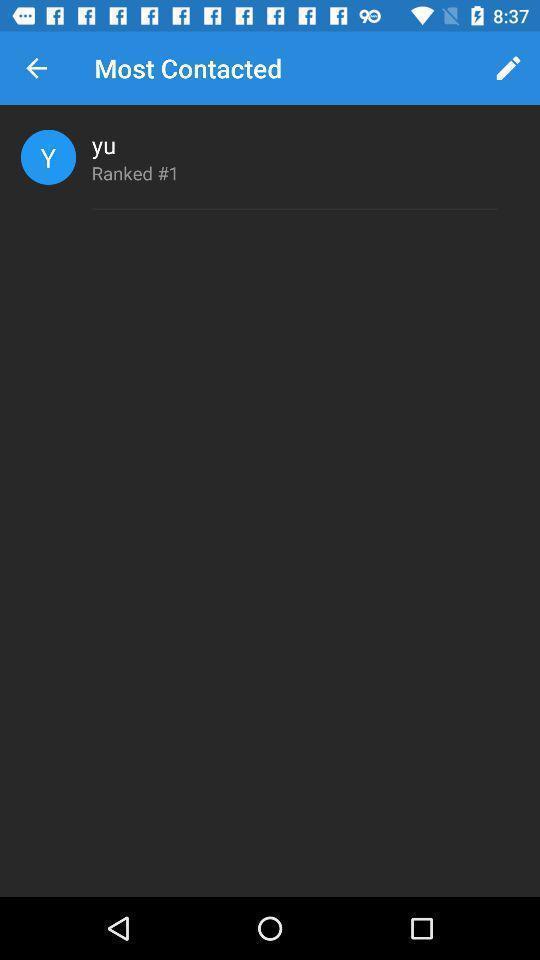What is the overall content of this screenshot? Screen shows most contacted person. 